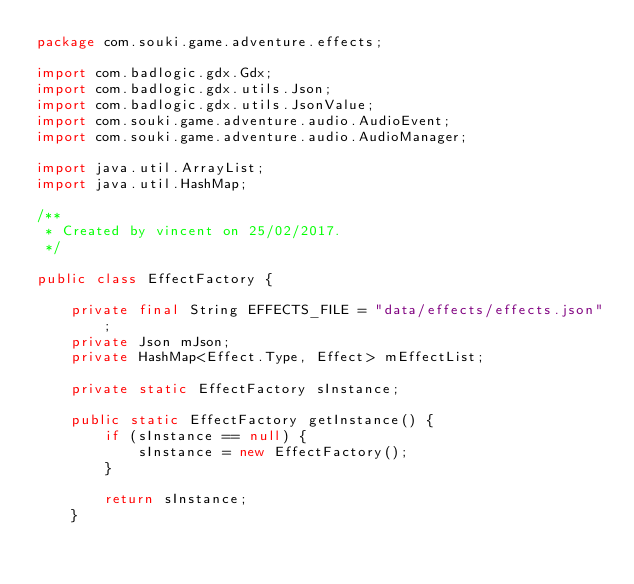Convert code to text. <code><loc_0><loc_0><loc_500><loc_500><_Java_>package com.souki.game.adventure.effects;

import com.badlogic.gdx.Gdx;
import com.badlogic.gdx.utils.Json;
import com.badlogic.gdx.utils.JsonValue;
import com.souki.game.adventure.audio.AudioEvent;
import com.souki.game.adventure.audio.AudioManager;

import java.util.ArrayList;
import java.util.HashMap;

/**
 * Created by vincent on 25/02/2017.
 */

public class EffectFactory {

    private final String EFFECTS_FILE = "data/effects/effects.json";
    private Json mJson;
    private HashMap<Effect.Type, Effect> mEffectList;

    private static EffectFactory sInstance;

    public static EffectFactory getInstance() {
        if (sInstance == null) {
            sInstance = new EffectFactory();
        }

        return sInstance;
    }
</code> 